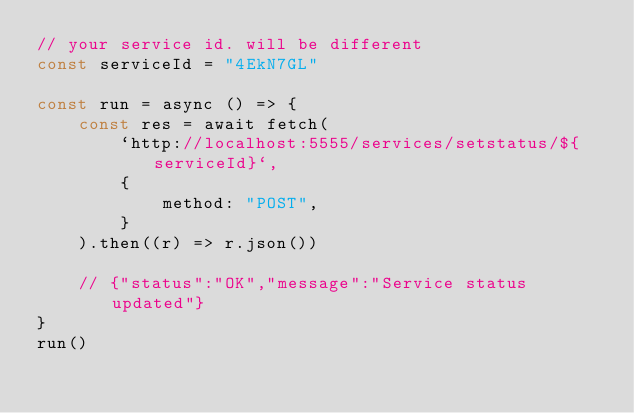Convert code to text. <code><loc_0><loc_0><loc_500><loc_500><_TypeScript_>// your service id. will be different
const serviceId = "4EkN7GL"

const run = async () => {
	const res = await fetch(
		`http://localhost:5555/services/setstatus/${serviceId}`,
		{
			method: "POST",
		}
	).then((r) => r.json())

	// {"status":"OK","message":"Service status updated"}
}
run()
</code> 